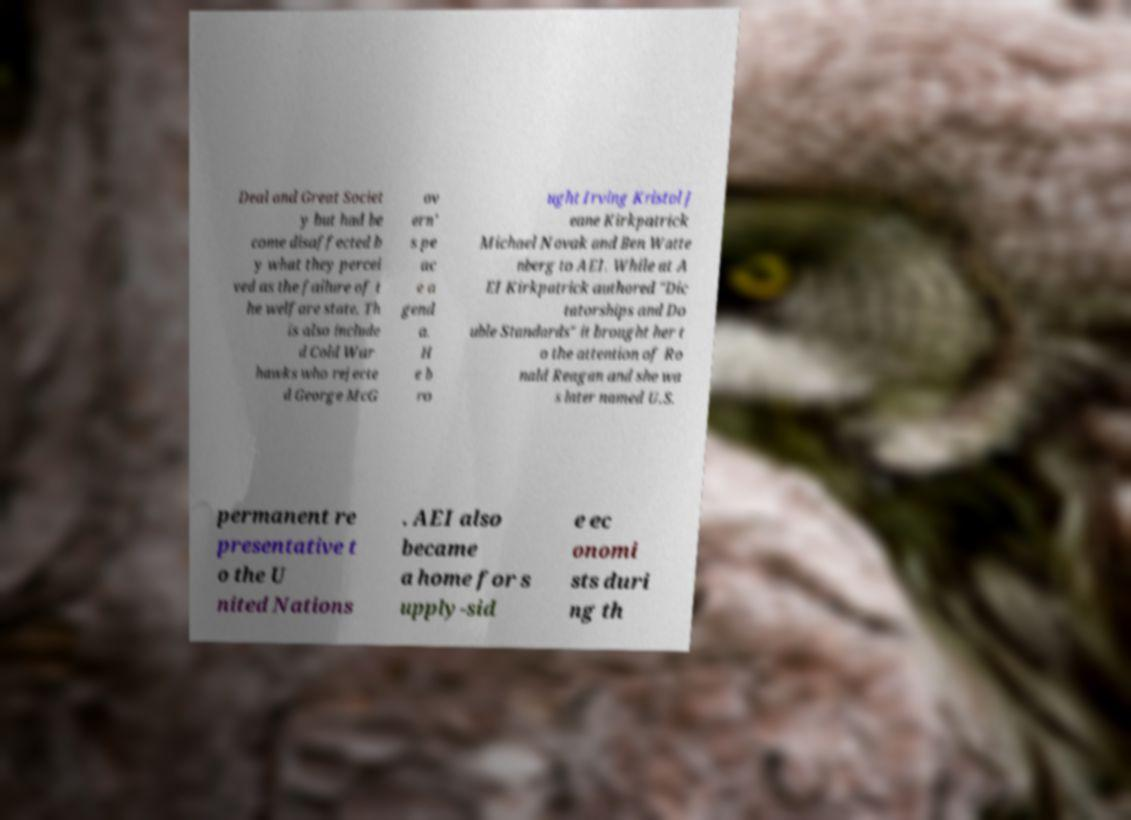There's text embedded in this image that I need extracted. Can you transcribe it verbatim? Deal and Great Societ y but had be come disaffected b y what they percei ved as the failure of t he welfare state. Th is also include d Cold War hawks who rejecte d George McG ov ern' s pe ac e a gend a. H e b ro ught Irving Kristol J eane Kirkpatrick Michael Novak and Ben Watte nberg to AEI. While at A EI Kirkpatrick authored "Dic tatorships and Do uble Standards" it brought her t o the attention of Ro nald Reagan and she wa s later named U.S. permanent re presentative t o the U nited Nations . AEI also became a home for s upply-sid e ec onomi sts duri ng th 